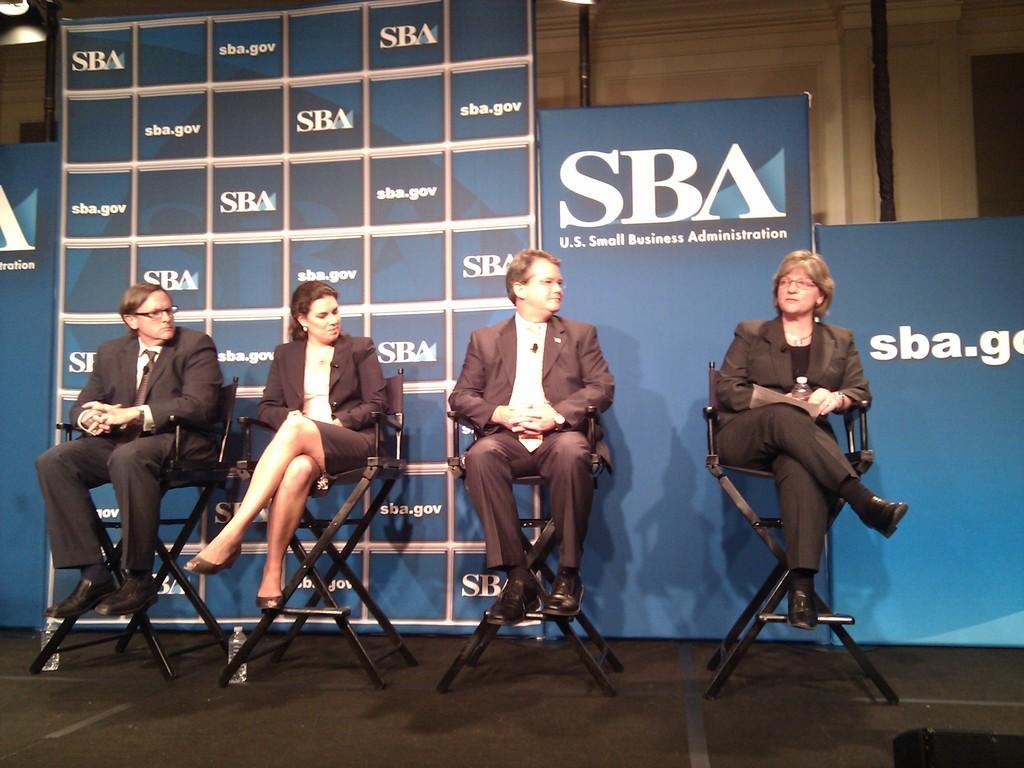Could you give a brief overview of what you see in this image? In this image I can see few people are sitting on chairs. 